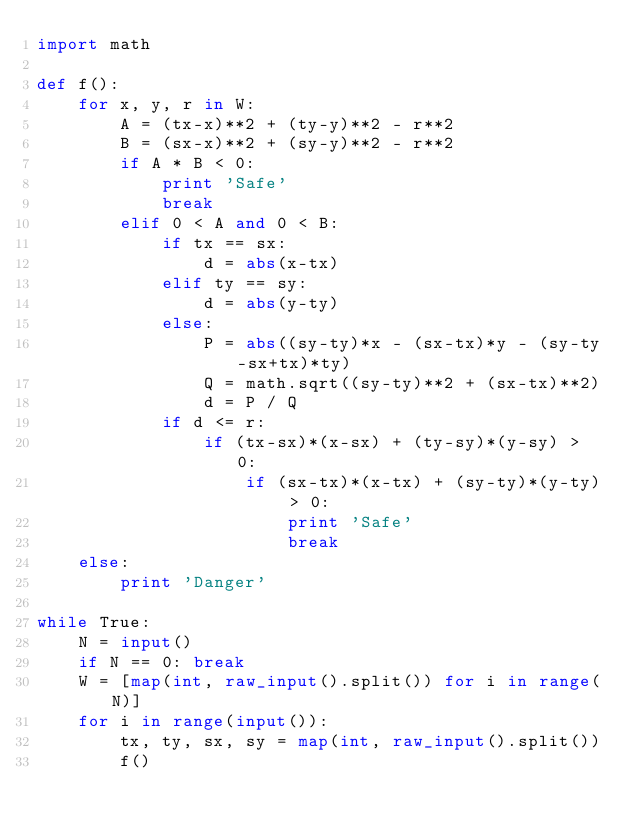<code> <loc_0><loc_0><loc_500><loc_500><_Python_>import math

def f():
    for x, y, r in W:
        A = (tx-x)**2 + (ty-y)**2 - r**2
        B = (sx-x)**2 + (sy-y)**2 - r**2
        if A * B < 0:
            print 'Safe'
            break
        elif 0 < A and 0 < B:
            if tx == sx:
                d = abs(x-tx)
            elif ty == sy:
                d = abs(y-ty)
            else:
                P = abs((sy-ty)*x - (sx-tx)*y - (sy-ty-sx+tx)*ty)
                Q = math.sqrt((sy-ty)**2 + (sx-tx)**2)
                d = P / Q
            if d <= r:
                if (tx-sx)*(x-sx) + (ty-sy)*(y-sy) > 0:
                    if (sx-tx)*(x-tx) + (sy-ty)*(y-ty) > 0:
                        print 'Safe'
                        break
    else:
        print 'Danger'
   
while True:
    N = input()
    if N == 0: break
    W = [map(int, raw_input().split()) for i in range(N)]
    for i in range(input()):
        tx, ty, sx, sy = map(int, raw_input().split())
        f()</code> 